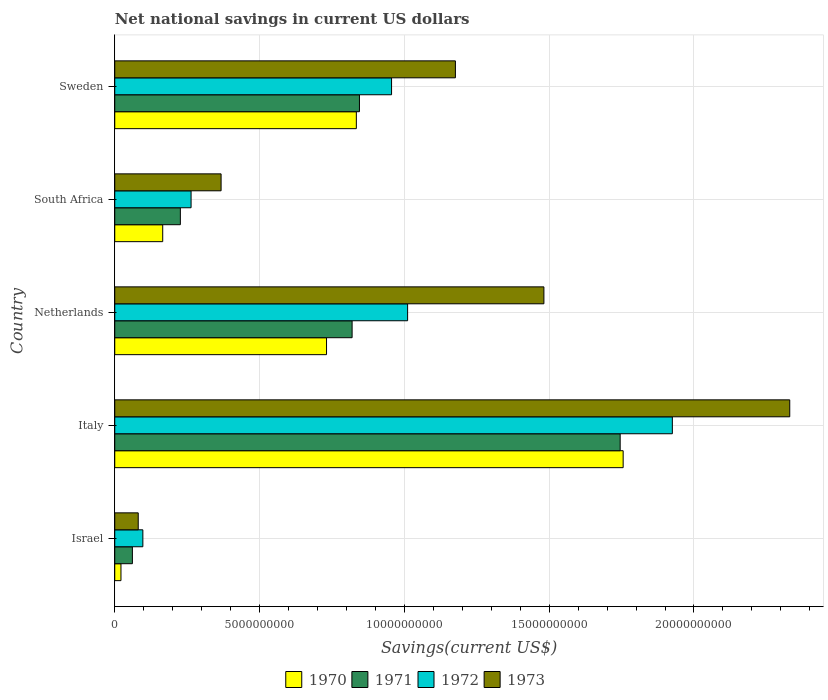What is the label of the 2nd group of bars from the top?
Give a very brief answer. South Africa. In how many cases, is the number of bars for a given country not equal to the number of legend labels?
Offer a very short reply. 0. What is the net national savings in 1970 in Israel?
Your answer should be compact. 2.15e+08. Across all countries, what is the maximum net national savings in 1972?
Provide a short and direct response. 1.93e+1. Across all countries, what is the minimum net national savings in 1970?
Offer a terse response. 2.15e+08. What is the total net national savings in 1973 in the graph?
Offer a very short reply. 5.44e+1. What is the difference between the net national savings in 1970 in Israel and that in Netherlands?
Your response must be concise. -7.10e+09. What is the difference between the net national savings in 1971 in Sweden and the net national savings in 1972 in South Africa?
Ensure brevity in your answer.  5.81e+09. What is the average net national savings in 1970 per country?
Your answer should be very brief. 7.02e+09. What is the difference between the net national savings in 1972 and net national savings in 1970 in Israel?
Offer a terse response. 7.56e+08. What is the ratio of the net national savings in 1970 in Italy to that in Sweden?
Your answer should be very brief. 2.1. Is the net national savings in 1973 in South Africa less than that in Sweden?
Provide a short and direct response. Yes. Is the difference between the net national savings in 1972 in Italy and Netherlands greater than the difference between the net national savings in 1970 in Italy and Netherlands?
Give a very brief answer. No. What is the difference between the highest and the second highest net national savings in 1972?
Provide a short and direct response. 9.14e+09. What is the difference between the highest and the lowest net national savings in 1973?
Offer a very short reply. 2.25e+1. Is the sum of the net national savings in 1973 in Italy and Netherlands greater than the maximum net national savings in 1971 across all countries?
Your response must be concise. Yes. Is it the case that in every country, the sum of the net national savings in 1973 and net national savings in 1972 is greater than the sum of net national savings in 1970 and net national savings in 1971?
Ensure brevity in your answer.  No. Is it the case that in every country, the sum of the net national savings in 1972 and net national savings in 1973 is greater than the net national savings in 1970?
Offer a terse response. Yes. How many countries are there in the graph?
Your response must be concise. 5. Are the values on the major ticks of X-axis written in scientific E-notation?
Make the answer very short. No. Does the graph contain any zero values?
Your response must be concise. No. Does the graph contain grids?
Provide a short and direct response. Yes. Where does the legend appear in the graph?
Give a very brief answer. Bottom center. How are the legend labels stacked?
Offer a very short reply. Horizontal. What is the title of the graph?
Offer a terse response. Net national savings in current US dollars. What is the label or title of the X-axis?
Keep it short and to the point. Savings(current US$). What is the Savings(current US$) of 1970 in Israel?
Offer a terse response. 2.15e+08. What is the Savings(current US$) in 1971 in Israel?
Your response must be concise. 6.09e+08. What is the Savings(current US$) of 1972 in Israel?
Provide a short and direct response. 9.71e+08. What is the Savings(current US$) of 1973 in Israel?
Give a very brief answer. 8.11e+08. What is the Savings(current US$) of 1970 in Italy?
Make the answer very short. 1.76e+1. What is the Savings(current US$) in 1971 in Italy?
Your response must be concise. 1.75e+1. What is the Savings(current US$) of 1972 in Italy?
Make the answer very short. 1.93e+1. What is the Savings(current US$) in 1973 in Italy?
Your answer should be compact. 2.33e+1. What is the Savings(current US$) of 1970 in Netherlands?
Offer a terse response. 7.31e+09. What is the Savings(current US$) in 1971 in Netherlands?
Provide a succinct answer. 8.20e+09. What is the Savings(current US$) of 1972 in Netherlands?
Your answer should be compact. 1.01e+1. What is the Savings(current US$) in 1973 in Netherlands?
Keep it short and to the point. 1.48e+1. What is the Savings(current US$) of 1970 in South Africa?
Your response must be concise. 1.66e+09. What is the Savings(current US$) of 1971 in South Africa?
Keep it short and to the point. 2.27e+09. What is the Savings(current US$) in 1972 in South Africa?
Offer a very short reply. 2.64e+09. What is the Savings(current US$) of 1973 in South Africa?
Give a very brief answer. 3.67e+09. What is the Savings(current US$) in 1970 in Sweden?
Give a very brief answer. 8.34e+09. What is the Savings(current US$) of 1971 in Sweden?
Provide a short and direct response. 8.45e+09. What is the Savings(current US$) of 1972 in Sweden?
Your answer should be very brief. 9.56e+09. What is the Savings(current US$) of 1973 in Sweden?
Make the answer very short. 1.18e+1. Across all countries, what is the maximum Savings(current US$) in 1970?
Keep it short and to the point. 1.76e+1. Across all countries, what is the maximum Savings(current US$) of 1971?
Provide a succinct answer. 1.75e+1. Across all countries, what is the maximum Savings(current US$) in 1972?
Your response must be concise. 1.93e+1. Across all countries, what is the maximum Savings(current US$) in 1973?
Offer a terse response. 2.33e+1. Across all countries, what is the minimum Savings(current US$) of 1970?
Your answer should be compact. 2.15e+08. Across all countries, what is the minimum Savings(current US$) of 1971?
Provide a succinct answer. 6.09e+08. Across all countries, what is the minimum Savings(current US$) in 1972?
Your answer should be very brief. 9.71e+08. Across all countries, what is the minimum Savings(current US$) in 1973?
Make the answer very short. 8.11e+08. What is the total Savings(current US$) in 1970 in the graph?
Make the answer very short. 3.51e+1. What is the total Savings(current US$) of 1971 in the graph?
Offer a terse response. 3.70e+1. What is the total Savings(current US$) of 1972 in the graph?
Offer a very short reply. 4.25e+1. What is the total Savings(current US$) of 1973 in the graph?
Provide a short and direct response. 5.44e+1. What is the difference between the Savings(current US$) in 1970 in Israel and that in Italy?
Give a very brief answer. -1.73e+1. What is the difference between the Savings(current US$) of 1971 in Israel and that in Italy?
Your answer should be very brief. -1.68e+1. What is the difference between the Savings(current US$) of 1972 in Israel and that in Italy?
Make the answer very short. -1.83e+1. What is the difference between the Savings(current US$) of 1973 in Israel and that in Italy?
Keep it short and to the point. -2.25e+1. What is the difference between the Savings(current US$) of 1970 in Israel and that in Netherlands?
Make the answer very short. -7.10e+09. What is the difference between the Savings(current US$) of 1971 in Israel and that in Netherlands?
Your response must be concise. -7.59e+09. What is the difference between the Savings(current US$) of 1972 in Israel and that in Netherlands?
Ensure brevity in your answer.  -9.14e+09. What is the difference between the Savings(current US$) of 1973 in Israel and that in Netherlands?
Ensure brevity in your answer.  -1.40e+1. What is the difference between the Savings(current US$) in 1970 in Israel and that in South Africa?
Offer a terse response. -1.44e+09. What is the difference between the Savings(current US$) in 1971 in Israel and that in South Africa?
Your response must be concise. -1.66e+09. What is the difference between the Savings(current US$) in 1972 in Israel and that in South Africa?
Provide a succinct answer. -1.66e+09. What is the difference between the Savings(current US$) in 1973 in Israel and that in South Africa?
Offer a very short reply. -2.86e+09. What is the difference between the Savings(current US$) in 1970 in Israel and that in Sweden?
Offer a very short reply. -8.13e+09. What is the difference between the Savings(current US$) in 1971 in Israel and that in Sweden?
Provide a succinct answer. -7.84e+09. What is the difference between the Savings(current US$) in 1972 in Israel and that in Sweden?
Give a very brief answer. -8.59e+09. What is the difference between the Savings(current US$) of 1973 in Israel and that in Sweden?
Make the answer very short. -1.10e+1. What is the difference between the Savings(current US$) of 1970 in Italy and that in Netherlands?
Keep it short and to the point. 1.02e+1. What is the difference between the Savings(current US$) in 1971 in Italy and that in Netherlands?
Give a very brief answer. 9.26e+09. What is the difference between the Savings(current US$) in 1972 in Italy and that in Netherlands?
Give a very brief answer. 9.14e+09. What is the difference between the Savings(current US$) of 1973 in Italy and that in Netherlands?
Your answer should be compact. 8.49e+09. What is the difference between the Savings(current US$) in 1970 in Italy and that in South Africa?
Offer a very short reply. 1.59e+1. What is the difference between the Savings(current US$) of 1971 in Italy and that in South Africa?
Offer a very short reply. 1.52e+1. What is the difference between the Savings(current US$) of 1972 in Italy and that in South Africa?
Provide a succinct answer. 1.66e+1. What is the difference between the Savings(current US$) of 1973 in Italy and that in South Africa?
Ensure brevity in your answer.  1.96e+1. What is the difference between the Savings(current US$) of 1970 in Italy and that in Sweden?
Make the answer very short. 9.21e+09. What is the difference between the Savings(current US$) of 1971 in Italy and that in Sweden?
Your response must be concise. 9.00e+09. What is the difference between the Savings(current US$) of 1972 in Italy and that in Sweden?
Keep it short and to the point. 9.70e+09. What is the difference between the Savings(current US$) of 1973 in Italy and that in Sweden?
Give a very brief answer. 1.15e+1. What is the difference between the Savings(current US$) of 1970 in Netherlands and that in South Africa?
Provide a short and direct response. 5.66e+09. What is the difference between the Savings(current US$) of 1971 in Netherlands and that in South Africa?
Ensure brevity in your answer.  5.93e+09. What is the difference between the Savings(current US$) of 1972 in Netherlands and that in South Africa?
Provide a succinct answer. 7.48e+09. What is the difference between the Savings(current US$) of 1973 in Netherlands and that in South Africa?
Keep it short and to the point. 1.11e+1. What is the difference between the Savings(current US$) in 1970 in Netherlands and that in Sweden?
Your answer should be compact. -1.03e+09. What is the difference between the Savings(current US$) of 1971 in Netherlands and that in Sweden?
Keep it short and to the point. -2.53e+08. What is the difference between the Savings(current US$) of 1972 in Netherlands and that in Sweden?
Your answer should be very brief. 5.54e+08. What is the difference between the Savings(current US$) of 1973 in Netherlands and that in Sweden?
Give a very brief answer. 3.06e+09. What is the difference between the Savings(current US$) of 1970 in South Africa and that in Sweden?
Offer a terse response. -6.69e+09. What is the difference between the Savings(current US$) of 1971 in South Africa and that in Sweden?
Keep it short and to the point. -6.18e+09. What is the difference between the Savings(current US$) of 1972 in South Africa and that in Sweden?
Offer a terse response. -6.92e+09. What is the difference between the Savings(current US$) of 1973 in South Africa and that in Sweden?
Provide a succinct answer. -8.09e+09. What is the difference between the Savings(current US$) in 1970 in Israel and the Savings(current US$) in 1971 in Italy?
Ensure brevity in your answer.  -1.72e+1. What is the difference between the Savings(current US$) in 1970 in Israel and the Savings(current US$) in 1972 in Italy?
Your response must be concise. -1.90e+1. What is the difference between the Savings(current US$) of 1970 in Israel and the Savings(current US$) of 1973 in Italy?
Keep it short and to the point. -2.31e+1. What is the difference between the Savings(current US$) of 1971 in Israel and the Savings(current US$) of 1972 in Italy?
Keep it short and to the point. -1.86e+1. What is the difference between the Savings(current US$) of 1971 in Israel and the Savings(current US$) of 1973 in Italy?
Offer a very short reply. -2.27e+1. What is the difference between the Savings(current US$) in 1972 in Israel and the Savings(current US$) in 1973 in Italy?
Your answer should be compact. -2.23e+1. What is the difference between the Savings(current US$) in 1970 in Israel and the Savings(current US$) in 1971 in Netherlands?
Your answer should be compact. -7.98e+09. What is the difference between the Savings(current US$) in 1970 in Israel and the Savings(current US$) in 1972 in Netherlands?
Make the answer very short. -9.90e+09. What is the difference between the Savings(current US$) of 1970 in Israel and the Savings(current US$) of 1973 in Netherlands?
Ensure brevity in your answer.  -1.46e+1. What is the difference between the Savings(current US$) in 1971 in Israel and the Savings(current US$) in 1972 in Netherlands?
Keep it short and to the point. -9.50e+09. What is the difference between the Savings(current US$) in 1971 in Israel and the Savings(current US$) in 1973 in Netherlands?
Keep it short and to the point. -1.42e+1. What is the difference between the Savings(current US$) of 1972 in Israel and the Savings(current US$) of 1973 in Netherlands?
Provide a short and direct response. -1.38e+1. What is the difference between the Savings(current US$) in 1970 in Israel and the Savings(current US$) in 1971 in South Africa?
Your answer should be compact. -2.05e+09. What is the difference between the Savings(current US$) in 1970 in Israel and the Savings(current US$) in 1972 in South Africa?
Offer a terse response. -2.42e+09. What is the difference between the Savings(current US$) in 1970 in Israel and the Savings(current US$) in 1973 in South Africa?
Provide a short and direct response. -3.46e+09. What is the difference between the Savings(current US$) of 1971 in Israel and the Savings(current US$) of 1972 in South Africa?
Offer a very short reply. -2.03e+09. What is the difference between the Savings(current US$) of 1971 in Israel and the Savings(current US$) of 1973 in South Africa?
Your answer should be compact. -3.06e+09. What is the difference between the Savings(current US$) of 1972 in Israel and the Savings(current US$) of 1973 in South Africa?
Keep it short and to the point. -2.70e+09. What is the difference between the Savings(current US$) of 1970 in Israel and the Savings(current US$) of 1971 in Sweden?
Make the answer very short. -8.23e+09. What is the difference between the Savings(current US$) in 1970 in Israel and the Savings(current US$) in 1972 in Sweden?
Your answer should be compact. -9.34e+09. What is the difference between the Savings(current US$) in 1970 in Israel and the Savings(current US$) in 1973 in Sweden?
Provide a succinct answer. -1.15e+1. What is the difference between the Savings(current US$) in 1971 in Israel and the Savings(current US$) in 1972 in Sweden?
Give a very brief answer. -8.95e+09. What is the difference between the Savings(current US$) in 1971 in Israel and the Savings(current US$) in 1973 in Sweden?
Offer a very short reply. -1.12e+1. What is the difference between the Savings(current US$) of 1972 in Israel and the Savings(current US$) of 1973 in Sweden?
Your answer should be very brief. -1.08e+1. What is the difference between the Savings(current US$) of 1970 in Italy and the Savings(current US$) of 1971 in Netherlands?
Your answer should be very brief. 9.36e+09. What is the difference between the Savings(current US$) of 1970 in Italy and the Savings(current US$) of 1972 in Netherlands?
Make the answer very short. 7.44e+09. What is the difference between the Savings(current US$) of 1970 in Italy and the Savings(current US$) of 1973 in Netherlands?
Offer a terse response. 2.74e+09. What is the difference between the Savings(current US$) of 1971 in Italy and the Savings(current US$) of 1972 in Netherlands?
Ensure brevity in your answer.  7.34e+09. What is the difference between the Savings(current US$) in 1971 in Italy and the Savings(current US$) in 1973 in Netherlands?
Your answer should be very brief. 2.63e+09. What is the difference between the Savings(current US$) in 1972 in Italy and the Savings(current US$) in 1973 in Netherlands?
Keep it short and to the point. 4.44e+09. What is the difference between the Savings(current US$) in 1970 in Italy and the Savings(current US$) in 1971 in South Africa?
Provide a succinct answer. 1.53e+1. What is the difference between the Savings(current US$) in 1970 in Italy and the Savings(current US$) in 1972 in South Africa?
Your response must be concise. 1.49e+1. What is the difference between the Savings(current US$) of 1970 in Italy and the Savings(current US$) of 1973 in South Africa?
Your answer should be compact. 1.39e+1. What is the difference between the Savings(current US$) of 1971 in Italy and the Savings(current US$) of 1972 in South Africa?
Make the answer very short. 1.48e+1. What is the difference between the Savings(current US$) in 1971 in Italy and the Savings(current US$) in 1973 in South Africa?
Your answer should be compact. 1.38e+1. What is the difference between the Savings(current US$) of 1972 in Italy and the Savings(current US$) of 1973 in South Africa?
Make the answer very short. 1.56e+1. What is the difference between the Savings(current US$) in 1970 in Italy and the Savings(current US$) in 1971 in Sweden?
Provide a short and direct response. 9.11e+09. What is the difference between the Savings(current US$) of 1970 in Italy and the Savings(current US$) of 1972 in Sweden?
Provide a short and direct response. 8.00e+09. What is the difference between the Savings(current US$) in 1970 in Italy and the Savings(current US$) in 1973 in Sweden?
Offer a very short reply. 5.79e+09. What is the difference between the Savings(current US$) in 1971 in Italy and the Savings(current US$) in 1972 in Sweden?
Offer a very short reply. 7.89e+09. What is the difference between the Savings(current US$) of 1971 in Italy and the Savings(current US$) of 1973 in Sweden?
Offer a terse response. 5.69e+09. What is the difference between the Savings(current US$) in 1972 in Italy and the Savings(current US$) in 1973 in Sweden?
Your answer should be compact. 7.49e+09. What is the difference between the Savings(current US$) of 1970 in Netherlands and the Savings(current US$) of 1971 in South Africa?
Ensure brevity in your answer.  5.05e+09. What is the difference between the Savings(current US$) of 1970 in Netherlands and the Savings(current US$) of 1972 in South Africa?
Provide a short and direct response. 4.68e+09. What is the difference between the Savings(current US$) in 1970 in Netherlands and the Savings(current US$) in 1973 in South Africa?
Provide a short and direct response. 3.64e+09. What is the difference between the Savings(current US$) of 1971 in Netherlands and the Savings(current US$) of 1972 in South Africa?
Provide a short and direct response. 5.56e+09. What is the difference between the Savings(current US$) of 1971 in Netherlands and the Savings(current US$) of 1973 in South Africa?
Your answer should be very brief. 4.52e+09. What is the difference between the Savings(current US$) of 1972 in Netherlands and the Savings(current US$) of 1973 in South Africa?
Give a very brief answer. 6.44e+09. What is the difference between the Savings(current US$) of 1970 in Netherlands and the Savings(current US$) of 1971 in Sweden?
Offer a very short reply. -1.14e+09. What is the difference between the Savings(current US$) in 1970 in Netherlands and the Savings(current US$) in 1972 in Sweden?
Provide a succinct answer. -2.25e+09. What is the difference between the Savings(current US$) in 1970 in Netherlands and the Savings(current US$) in 1973 in Sweden?
Ensure brevity in your answer.  -4.45e+09. What is the difference between the Savings(current US$) of 1971 in Netherlands and the Savings(current US$) of 1972 in Sweden?
Your response must be concise. -1.36e+09. What is the difference between the Savings(current US$) in 1971 in Netherlands and the Savings(current US$) in 1973 in Sweden?
Your response must be concise. -3.57e+09. What is the difference between the Savings(current US$) of 1972 in Netherlands and the Savings(current US$) of 1973 in Sweden?
Your response must be concise. -1.65e+09. What is the difference between the Savings(current US$) in 1970 in South Africa and the Savings(current US$) in 1971 in Sweden?
Make the answer very short. -6.79e+09. What is the difference between the Savings(current US$) of 1970 in South Africa and the Savings(current US$) of 1972 in Sweden?
Give a very brief answer. -7.90e+09. What is the difference between the Savings(current US$) of 1970 in South Africa and the Savings(current US$) of 1973 in Sweden?
Give a very brief answer. -1.01e+1. What is the difference between the Savings(current US$) of 1971 in South Africa and the Savings(current US$) of 1972 in Sweden?
Offer a terse response. -7.29e+09. What is the difference between the Savings(current US$) in 1971 in South Africa and the Savings(current US$) in 1973 in Sweden?
Ensure brevity in your answer.  -9.50e+09. What is the difference between the Savings(current US$) of 1972 in South Africa and the Savings(current US$) of 1973 in Sweden?
Offer a terse response. -9.13e+09. What is the average Savings(current US$) in 1970 per country?
Give a very brief answer. 7.02e+09. What is the average Savings(current US$) of 1971 per country?
Ensure brevity in your answer.  7.39e+09. What is the average Savings(current US$) of 1972 per country?
Your response must be concise. 8.51e+09. What is the average Savings(current US$) in 1973 per country?
Ensure brevity in your answer.  1.09e+1. What is the difference between the Savings(current US$) in 1970 and Savings(current US$) in 1971 in Israel?
Give a very brief answer. -3.94e+08. What is the difference between the Savings(current US$) in 1970 and Savings(current US$) in 1972 in Israel?
Provide a short and direct response. -7.56e+08. What is the difference between the Savings(current US$) in 1970 and Savings(current US$) in 1973 in Israel?
Make the answer very short. -5.96e+08. What is the difference between the Savings(current US$) of 1971 and Savings(current US$) of 1972 in Israel?
Your answer should be very brief. -3.62e+08. What is the difference between the Savings(current US$) of 1971 and Savings(current US$) of 1973 in Israel?
Make the answer very short. -2.02e+08. What is the difference between the Savings(current US$) in 1972 and Savings(current US$) in 1973 in Israel?
Provide a short and direct response. 1.60e+08. What is the difference between the Savings(current US$) in 1970 and Savings(current US$) in 1971 in Italy?
Provide a short and direct response. 1.03e+08. What is the difference between the Savings(current US$) of 1970 and Savings(current US$) of 1972 in Italy?
Ensure brevity in your answer.  -1.70e+09. What is the difference between the Savings(current US$) of 1970 and Savings(current US$) of 1973 in Italy?
Your answer should be compact. -5.75e+09. What is the difference between the Savings(current US$) in 1971 and Savings(current US$) in 1972 in Italy?
Give a very brief answer. -1.80e+09. What is the difference between the Savings(current US$) in 1971 and Savings(current US$) in 1973 in Italy?
Keep it short and to the point. -5.86e+09. What is the difference between the Savings(current US$) in 1972 and Savings(current US$) in 1973 in Italy?
Your answer should be compact. -4.05e+09. What is the difference between the Savings(current US$) of 1970 and Savings(current US$) of 1971 in Netherlands?
Give a very brief answer. -8.83e+08. What is the difference between the Savings(current US$) of 1970 and Savings(current US$) of 1972 in Netherlands?
Your answer should be compact. -2.80e+09. What is the difference between the Savings(current US$) in 1970 and Savings(current US$) in 1973 in Netherlands?
Provide a short and direct response. -7.51e+09. What is the difference between the Savings(current US$) of 1971 and Savings(current US$) of 1972 in Netherlands?
Provide a succinct answer. -1.92e+09. What is the difference between the Savings(current US$) of 1971 and Savings(current US$) of 1973 in Netherlands?
Ensure brevity in your answer.  -6.62e+09. What is the difference between the Savings(current US$) in 1972 and Savings(current US$) in 1973 in Netherlands?
Your answer should be very brief. -4.71e+09. What is the difference between the Savings(current US$) of 1970 and Savings(current US$) of 1971 in South Africa?
Your answer should be very brief. -6.09e+08. What is the difference between the Savings(current US$) of 1970 and Savings(current US$) of 1972 in South Africa?
Keep it short and to the point. -9.79e+08. What is the difference between the Savings(current US$) of 1970 and Savings(current US$) of 1973 in South Africa?
Keep it short and to the point. -2.02e+09. What is the difference between the Savings(current US$) of 1971 and Savings(current US$) of 1972 in South Africa?
Your response must be concise. -3.70e+08. What is the difference between the Savings(current US$) of 1971 and Savings(current US$) of 1973 in South Africa?
Offer a terse response. -1.41e+09. What is the difference between the Savings(current US$) of 1972 and Savings(current US$) of 1973 in South Africa?
Provide a short and direct response. -1.04e+09. What is the difference between the Savings(current US$) of 1970 and Savings(current US$) of 1971 in Sweden?
Ensure brevity in your answer.  -1.07e+08. What is the difference between the Savings(current US$) of 1970 and Savings(current US$) of 1972 in Sweden?
Your answer should be compact. -1.22e+09. What is the difference between the Savings(current US$) in 1970 and Savings(current US$) in 1973 in Sweden?
Provide a short and direct response. -3.42e+09. What is the difference between the Savings(current US$) in 1971 and Savings(current US$) in 1972 in Sweden?
Your response must be concise. -1.11e+09. What is the difference between the Savings(current US$) of 1971 and Savings(current US$) of 1973 in Sweden?
Your answer should be very brief. -3.31e+09. What is the difference between the Savings(current US$) in 1972 and Savings(current US$) in 1973 in Sweden?
Make the answer very short. -2.20e+09. What is the ratio of the Savings(current US$) of 1970 in Israel to that in Italy?
Provide a short and direct response. 0.01. What is the ratio of the Savings(current US$) of 1971 in Israel to that in Italy?
Give a very brief answer. 0.03. What is the ratio of the Savings(current US$) in 1972 in Israel to that in Italy?
Your answer should be compact. 0.05. What is the ratio of the Savings(current US$) of 1973 in Israel to that in Italy?
Provide a short and direct response. 0.03. What is the ratio of the Savings(current US$) in 1970 in Israel to that in Netherlands?
Offer a terse response. 0.03. What is the ratio of the Savings(current US$) of 1971 in Israel to that in Netherlands?
Your response must be concise. 0.07. What is the ratio of the Savings(current US$) of 1972 in Israel to that in Netherlands?
Provide a short and direct response. 0.1. What is the ratio of the Savings(current US$) in 1973 in Israel to that in Netherlands?
Provide a short and direct response. 0.05. What is the ratio of the Savings(current US$) in 1970 in Israel to that in South Africa?
Provide a succinct answer. 0.13. What is the ratio of the Savings(current US$) of 1971 in Israel to that in South Africa?
Ensure brevity in your answer.  0.27. What is the ratio of the Savings(current US$) in 1972 in Israel to that in South Africa?
Provide a succinct answer. 0.37. What is the ratio of the Savings(current US$) of 1973 in Israel to that in South Africa?
Give a very brief answer. 0.22. What is the ratio of the Savings(current US$) in 1970 in Israel to that in Sweden?
Provide a short and direct response. 0.03. What is the ratio of the Savings(current US$) of 1971 in Israel to that in Sweden?
Keep it short and to the point. 0.07. What is the ratio of the Savings(current US$) of 1972 in Israel to that in Sweden?
Keep it short and to the point. 0.1. What is the ratio of the Savings(current US$) in 1973 in Israel to that in Sweden?
Make the answer very short. 0.07. What is the ratio of the Savings(current US$) in 1970 in Italy to that in Netherlands?
Your answer should be compact. 2.4. What is the ratio of the Savings(current US$) of 1971 in Italy to that in Netherlands?
Give a very brief answer. 2.13. What is the ratio of the Savings(current US$) of 1972 in Italy to that in Netherlands?
Provide a short and direct response. 1.9. What is the ratio of the Savings(current US$) in 1973 in Italy to that in Netherlands?
Ensure brevity in your answer.  1.57. What is the ratio of the Savings(current US$) of 1970 in Italy to that in South Africa?
Offer a terse response. 10.6. What is the ratio of the Savings(current US$) of 1971 in Italy to that in South Africa?
Your answer should be compact. 7.7. What is the ratio of the Savings(current US$) in 1972 in Italy to that in South Africa?
Keep it short and to the point. 7.31. What is the ratio of the Savings(current US$) of 1973 in Italy to that in South Africa?
Give a very brief answer. 6.35. What is the ratio of the Savings(current US$) in 1970 in Italy to that in Sweden?
Your response must be concise. 2.1. What is the ratio of the Savings(current US$) of 1971 in Italy to that in Sweden?
Your answer should be very brief. 2.07. What is the ratio of the Savings(current US$) in 1972 in Italy to that in Sweden?
Make the answer very short. 2.01. What is the ratio of the Savings(current US$) in 1973 in Italy to that in Sweden?
Offer a terse response. 1.98. What is the ratio of the Savings(current US$) in 1970 in Netherlands to that in South Africa?
Offer a very short reply. 4.42. What is the ratio of the Savings(current US$) of 1971 in Netherlands to that in South Africa?
Your response must be concise. 3.62. What is the ratio of the Savings(current US$) in 1972 in Netherlands to that in South Africa?
Make the answer very short. 3.84. What is the ratio of the Savings(current US$) in 1973 in Netherlands to that in South Africa?
Provide a short and direct response. 4.04. What is the ratio of the Savings(current US$) in 1970 in Netherlands to that in Sweden?
Provide a succinct answer. 0.88. What is the ratio of the Savings(current US$) in 1972 in Netherlands to that in Sweden?
Ensure brevity in your answer.  1.06. What is the ratio of the Savings(current US$) in 1973 in Netherlands to that in Sweden?
Your answer should be very brief. 1.26. What is the ratio of the Savings(current US$) in 1970 in South Africa to that in Sweden?
Offer a very short reply. 0.2. What is the ratio of the Savings(current US$) in 1971 in South Africa to that in Sweden?
Give a very brief answer. 0.27. What is the ratio of the Savings(current US$) in 1972 in South Africa to that in Sweden?
Offer a terse response. 0.28. What is the ratio of the Savings(current US$) of 1973 in South Africa to that in Sweden?
Offer a terse response. 0.31. What is the difference between the highest and the second highest Savings(current US$) of 1970?
Offer a terse response. 9.21e+09. What is the difference between the highest and the second highest Savings(current US$) in 1971?
Your answer should be compact. 9.00e+09. What is the difference between the highest and the second highest Savings(current US$) of 1972?
Provide a succinct answer. 9.14e+09. What is the difference between the highest and the second highest Savings(current US$) in 1973?
Provide a succinct answer. 8.49e+09. What is the difference between the highest and the lowest Savings(current US$) of 1970?
Your answer should be very brief. 1.73e+1. What is the difference between the highest and the lowest Savings(current US$) of 1971?
Ensure brevity in your answer.  1.68e+1. What is the difference between the highest and the lowest Savings(current US$) in 1972?
Offer a very short reply. 1.83e+1. What is the difference between the highest and the lowest Savings(current US$) of 1973?
Offer a terse response. 2.25e+1. 